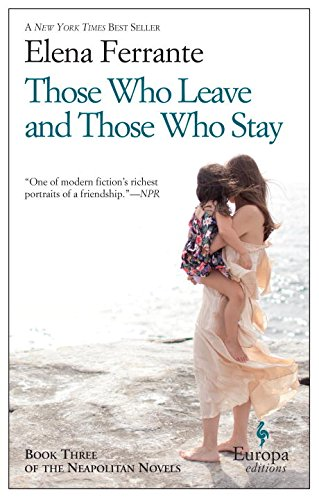What is the title of this book? The title of this book is 'Those Who Leave and Those Who Stay: Neapolitan Novels, Book Three', which is the third installment in Ferrante's critically acclaimed Neapolitan series, exploring intricate human emotions and relationships. 